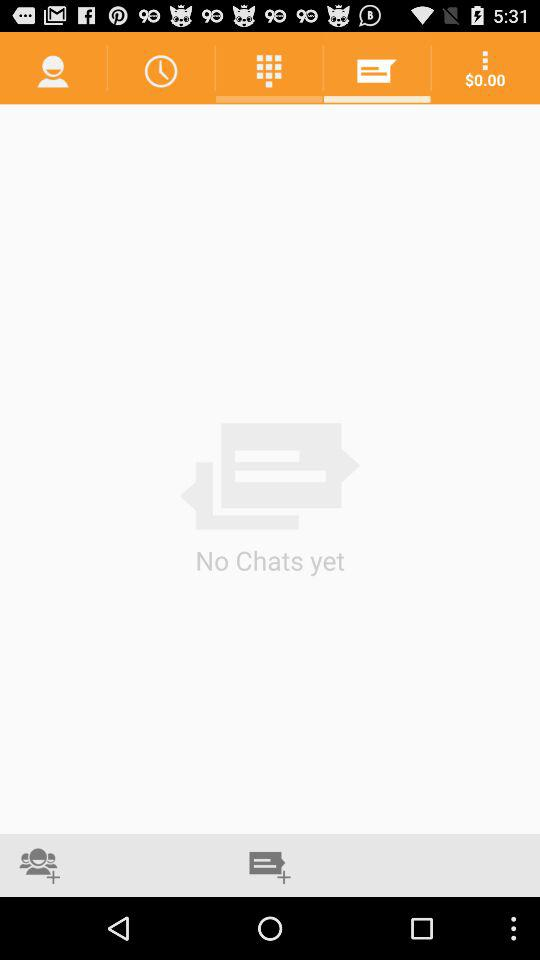Which tab is selected?
When the provided information is insufficient, respond with <no answer>. <no answer> 